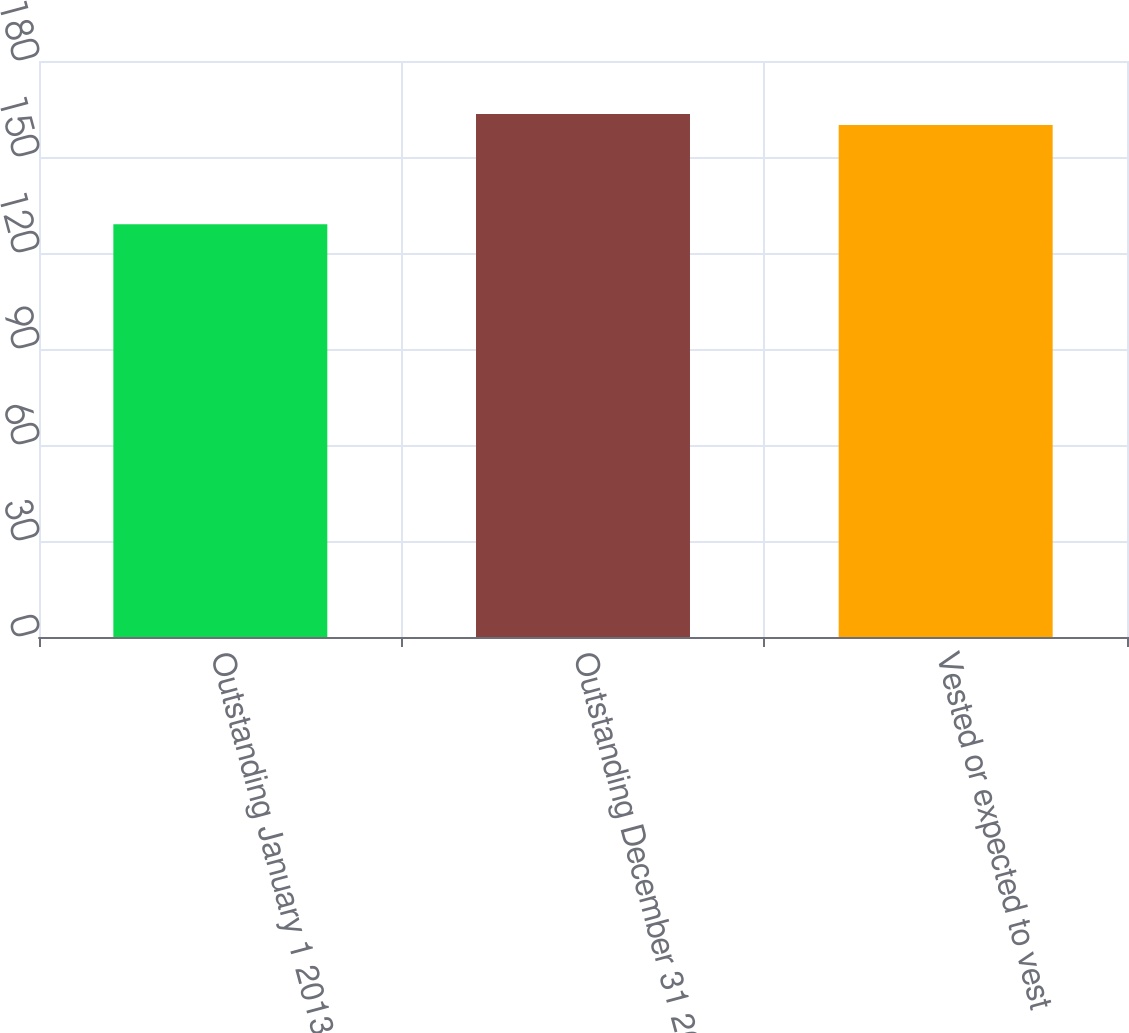<chart> <loc_0><loc_0><loc_500><loc_500><bar_chart><fcel>Outstanding January 1 2013<fcel>Outstanding December 31 2013<fcel>Vested or expected to vest<nl><fcel>129<fcel>163.4<fcel>160<nl></chart> 